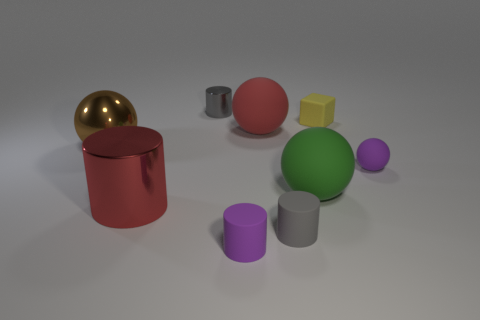The object that is the same color as the tiny matte sphere is what size?
Your response must be concise. Small. What number of tiny gray things are left of the purple matte cylinder and in front of the small yellow block?
Keep it short and to the point. 0. There is a green object that is to the right of the ball that is on the left side of the red rubber sphere; what is its size?
Ensure brevity in your answer.  Large. Are there fewer small purple cylinders that are on the left side of the tiny metallic object than small purple spheres behind the large shiny cylinder?
Your response must be concise. Yes. Do the big matte ball that is left of the green matte thing and the big shiny cylinder behind the tiny gray matte object have the same color?
Your answer should be compact. Yes. The cylinder that is both right of the large metal cylinder and behind the small gray matte thing is made of what material?
Your response must be concise. Metal. Are there any matte balls?
Your answer should be compact. Yes. There is a red object that is the same material as the block; what shape is it?
Keep it short and to the point. Sphere. There is a tiny metal object; is its shape the same as the small purple rubber thing to the left of the tiny yellow thing?
Your response must be concise. Yes. The small purple object that is in front of the object that is to the right of the small yellow cube is made of what material?
Offer a very short reply. Rubber. 